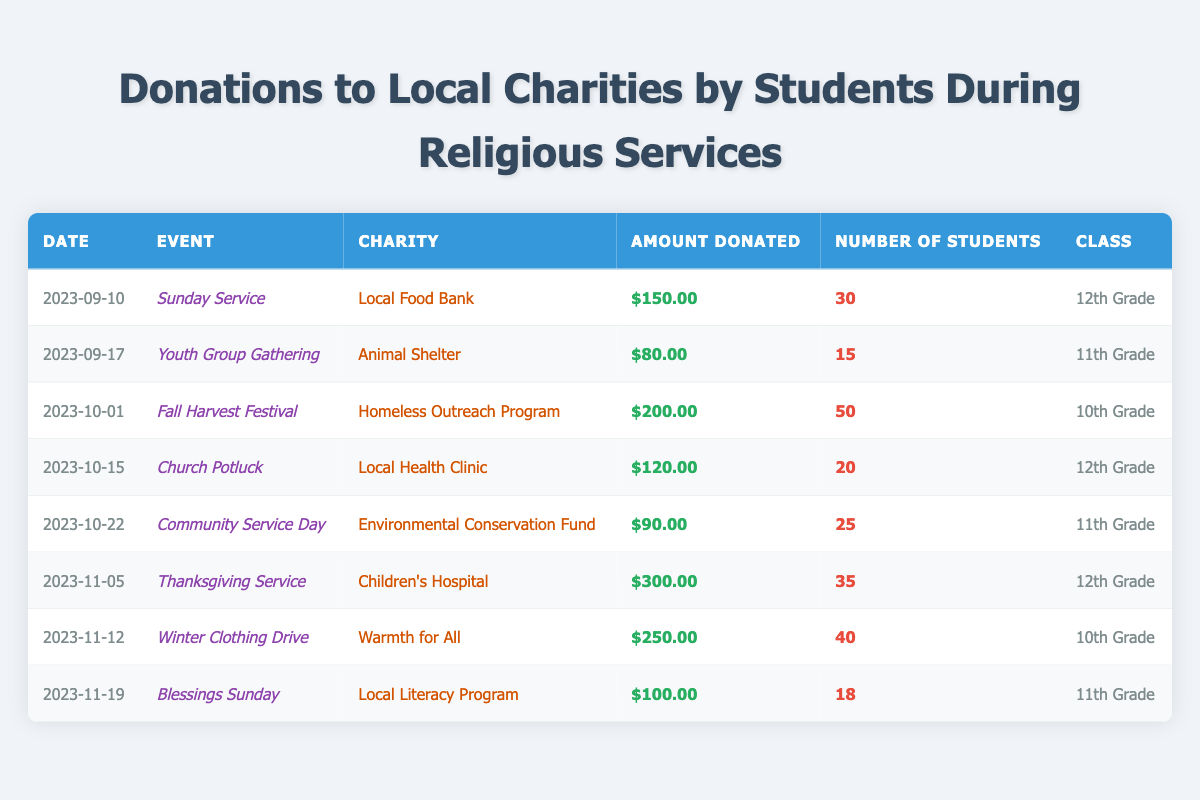What is the total amount donated by the 12th Grade? To find the total amount donated by the 12th Grade, we need to look for all entries associated with this class. There are two donations: $150.00 (Sunday Service) and $300.00 (Thanksgiving Service). Adding these amounts gives us 150 + 300 = $450.00.
Answer: $450.00 Which charity received the highest donation amount? By examining the donation amounts, the highest value is $300.00 donated to Children's Hospital during the Thanksgiving Service.
Answer: Children's Hospital How many students contributed to the Winter Clothing Drive? The Winter Clothing Drive on 2023-11-12 had 40 students contributing, as indicated in the table.
Answer: 40 What is the average amount donated by the 11th Grade students? To calculate the average for the 11th Grade, we first identify their donations: $80.00 (Youth Group Gathering), $90.00 (Community Service Day), and $100.00 (Blessings Sunday). Summing these amounts gives 80 + 90 + 100 = $270.00, and there are 3 entries. Therefore, the average is 270 / 3 = $90.00.
Answer: $90.00 Did the 10th Grade donate more than the 11th Grade? The 10th Grade donated $200.00 (Fall Harvest Festival) + $250.00 (Winter Clothing Drive) = $450.00 in total. The 11th Grade's total is $80.00 + $90.00 + $100.00 = $270.00. Since $450.00 > $270.00, the 10th Grade donated more.
Answer: Yes What was the total number of students that participated in the donations to the Local Food Bank and the Children's Hospital? For the Local Food Bank (2023-09-10), there were 30 students. For the Children's Hospital (2023-11-05), there were 35 students. Adding these gives us 30 + 35 = 65.
Answer: 65 Which event had the most student participation overall? The Fall Harvest Festival had the highest number of participating students at 50, which is more than any other event listed in the table.
Answer: Fall Harvest Festival What percentage of the total donations came from the Homeless Outreach Program? The total amount donated across all events is $150.00 + $80.00 + $200.00 + $120.00 + $90.00 + $300.00 + $250.00 + $100.00 = $1,080.00. The Homeless Outreach Program received $200.00. To find the percentage, (200 / 1080) * 100 = 18.52%.
Answer: 18.52% Was there any donation made to charity related to environmental causes? Yes, there was a donation made to the Environmental Conservation Fund during the Community Service Day event, which is recorded in the table.
Answer: Yes How many donations were made for events that included the word "Service"? The events with "Service" in their titles are Sunday Service, Thanksgiving Service, and Winter Clothing Drive. This gives us a total of 3 donations.
Answer: 3 